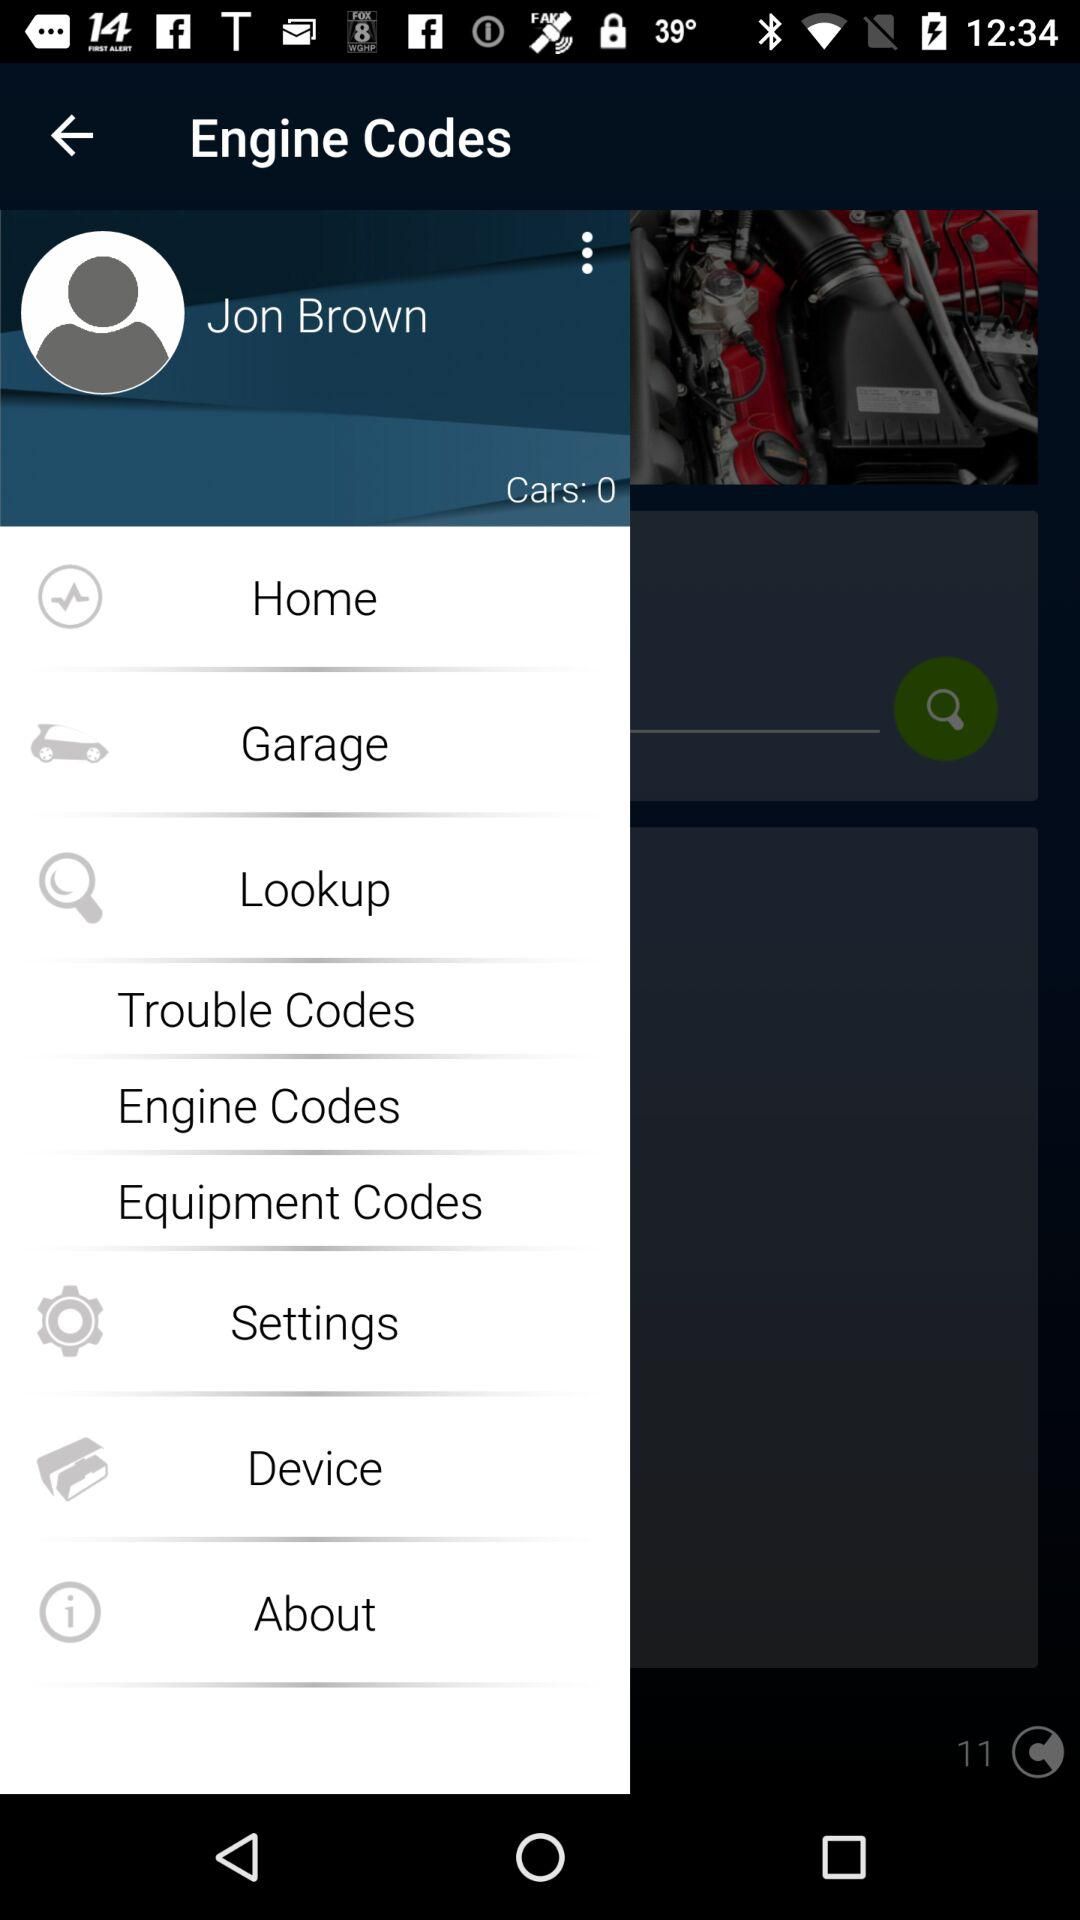What is the number of cars? The number of cars is 0. 